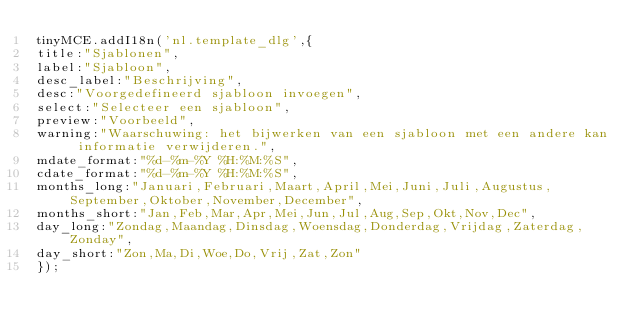Convert code to text. <code><loc_0><loc_0><loc_500><loc_500><_JavaScript_>tinyMCE.addI18n('nl.template_dlg',{
title:"Sjablonen",
label:"Sjabloon",
desc_label:"Beschrijving",
desc:"Voorgedefineerd sjabloon invoegen",
select:"Selecteer een sjabloon",
preview:"Voorbeeld",
warning:"Waarschuwing: het bijwerken van een sjabloon met een andere kan informatie verwijderen.",
mdate_format:"%d-%m-%Y %H:%M:%S",
cdate_format:"%d-%m-%Y %H:%M:%S",
months_long:"Januari,Februari,Maart,April,Mei,Juni,Juli,Augustus,September,Oktober,November,December",
months_short:"Jan,Feb,Mar,Apr,Mei,Jun,Jul,Aug,Sep,Okt,Nov,Dec",
day_long:"Zondag,Maandag,Dinsdag,Woensdag,Donderdag,Vrijdag,Zaterdag,Zonday",
day_short:"Zon,Ma,Di,Woe,Do,Vrij,Zat,Zon"
});</code> 